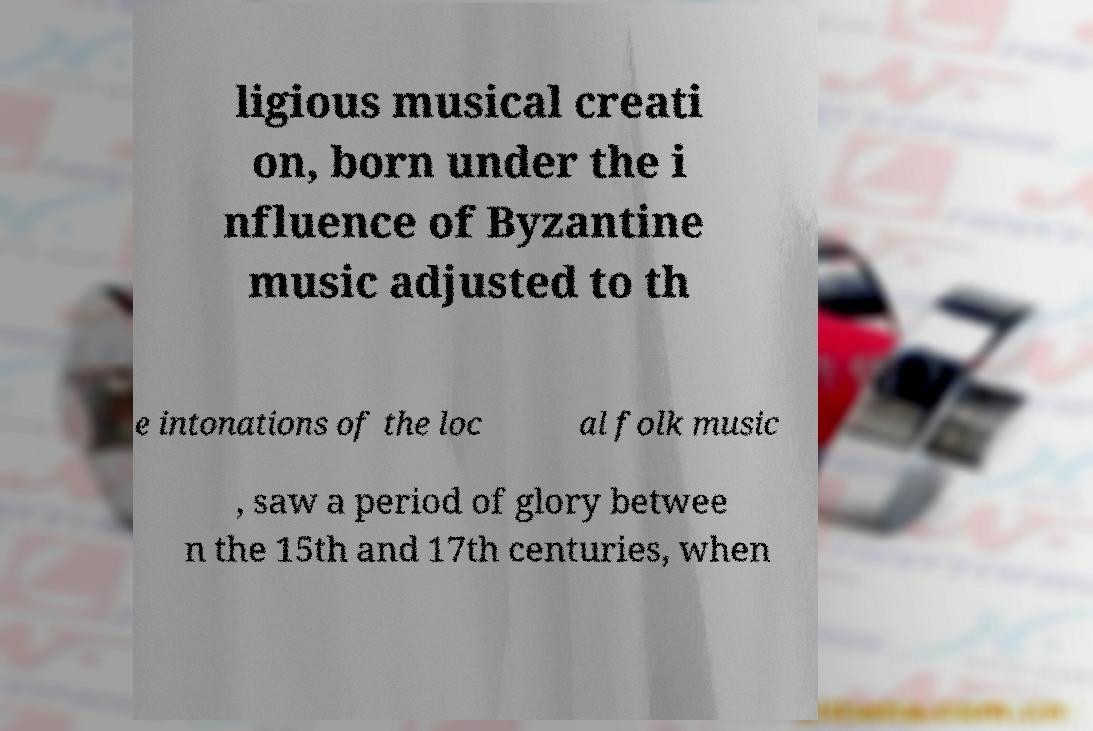Please identify and transcribe the text found in this image. ligious musical creati on, born under the i nfluence of Byzantine music adjusted to th e intonations of the loc al folk music , saw a period of glory betwee n the 15th and 17th centuries, when 